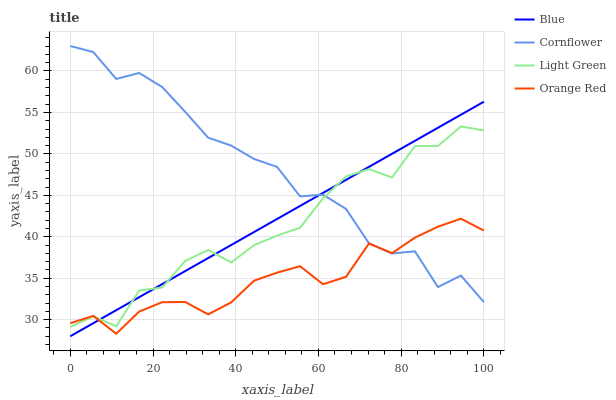Does Orange Red have the minimum area under the curve?
Answer yes or no. Yes. Does Cornflower have the maximum area under the curve?
Answer yes or no. Yes. Does Cornflower have the minimum area under the curve?
Answer yes or no. No. Does Orange Red have the maximum area under the curve?
Answer yes or no. No. Is Blue the smoothest?
Answer yes or no. Yes. Is Light Green the roughest?
Answer yes or no. Yes. Is Cornflower the smoothest?
Answer yes or no. No. Is Cornflower the roughest?
Answer yes or no. No. Does Blue have the lowest value?
Answer yes or no. Yes. Does Orange Red have the lowest value?
Answer yes or no. No. Does Cornflower have the highest value?
Answer yes or no. Yes. Does Orange Red have the highest value?
Answer yes or no. No. Does Cornflower intersect Light Green?
Answer yes or no. Yes. Is Cornflower less than Light Green?
Answer yes or no. No. Is Cornflower greater than Light Green?
Answer yes or no. No. 